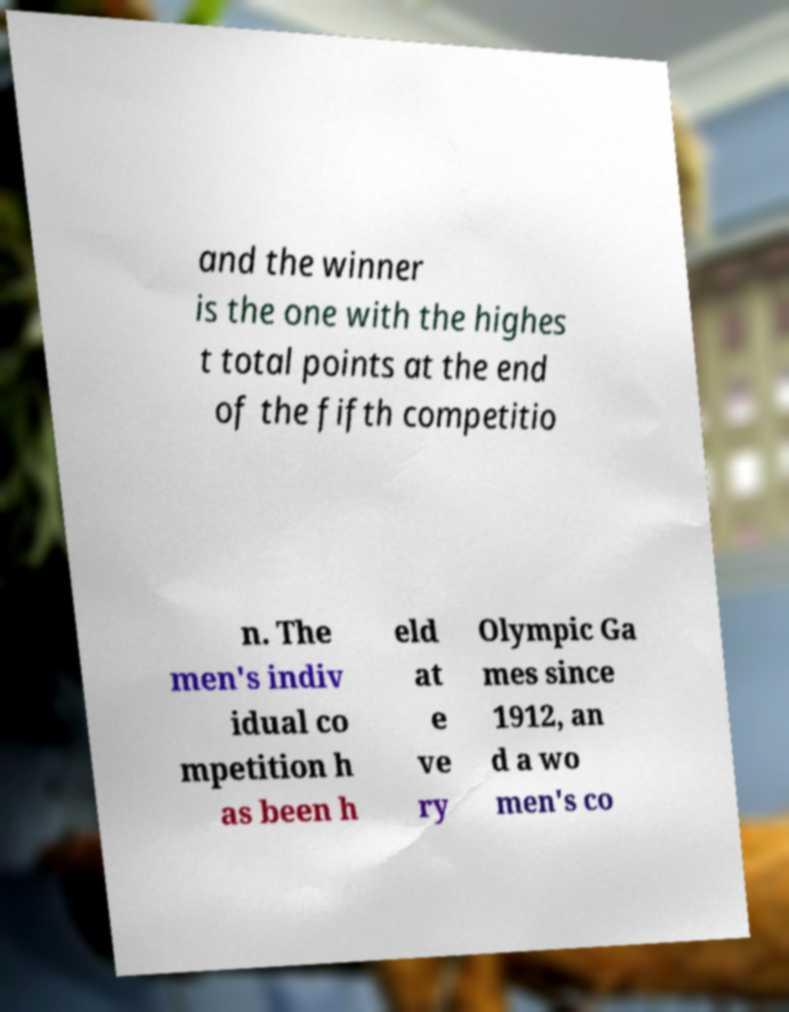What messages or text are displayed in this image? I need them in a readable, typed format. and the winner is the one with the highes t total points at the end of the fifth competitio n. The men's indiv idual co mpetition h as been h eld at e ve ry Olympic Ga mes since 1912, an d a wo men's co 